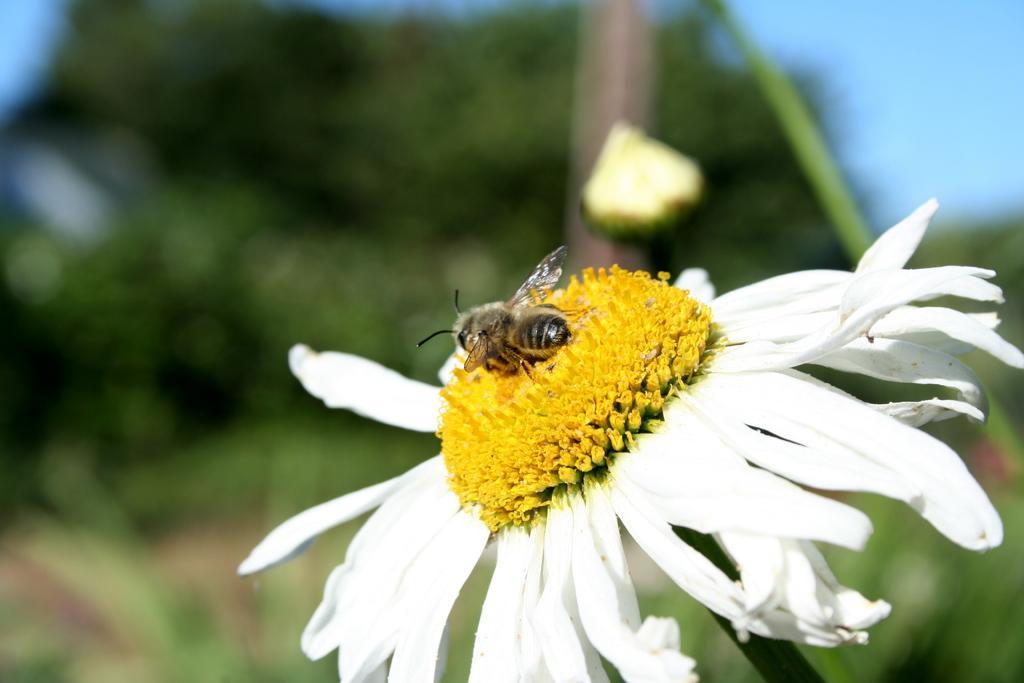Could you give a brief overview of what you see in this image? In this image I can see a flower which is white and yellow in color and on it I can see an insect which is black in color. I can see the blurry background in which I can see few trees and the sky. 